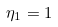<formula> <loc_0><loc_0><loc_500><loc_500>\eta _ { 1 } = 1</formula> 